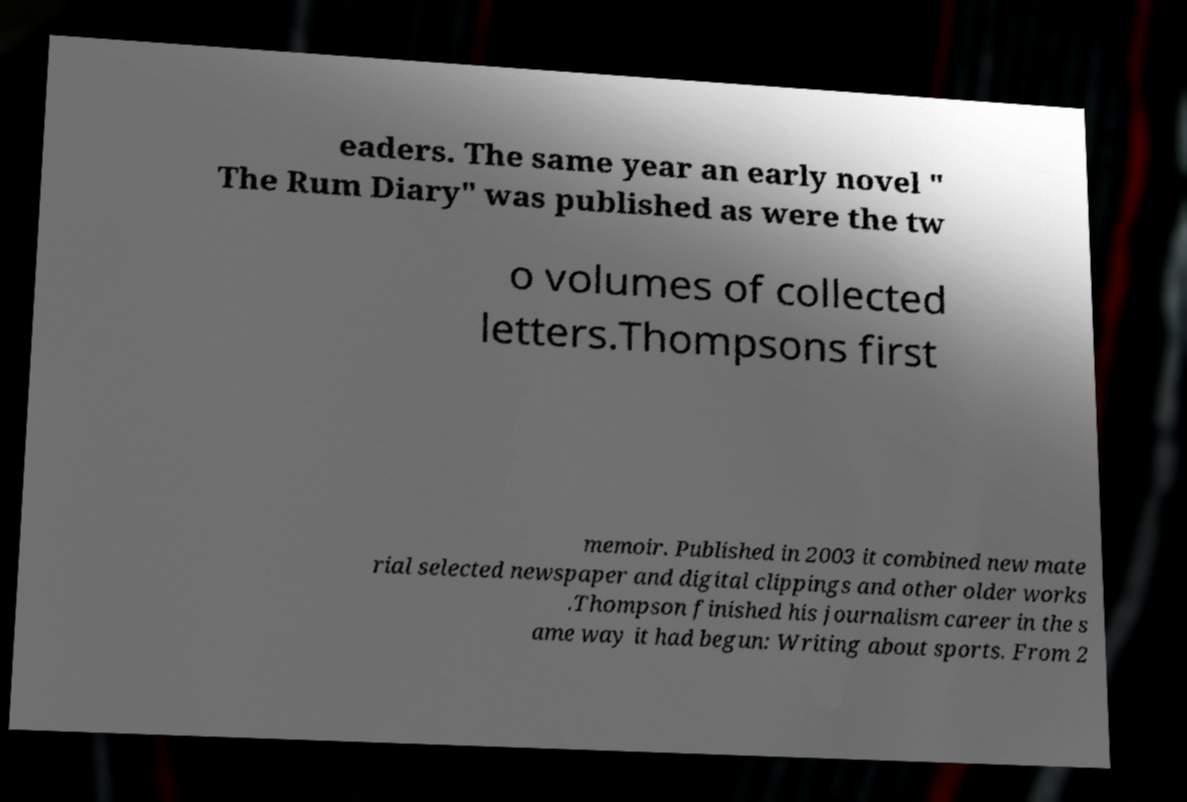Please read and relay the text visible in this image. What does it say? eaders. The same year an early novel " The Rum Diary" was published as were the tw o volumes of collected letters.Thompsons first memoir. Published in 2003 it combined new mate rial selected newspaper and digital clippings and other older works .Thompson finished his journalism career in the s ame way it had begun: Writing about sports. From 2 